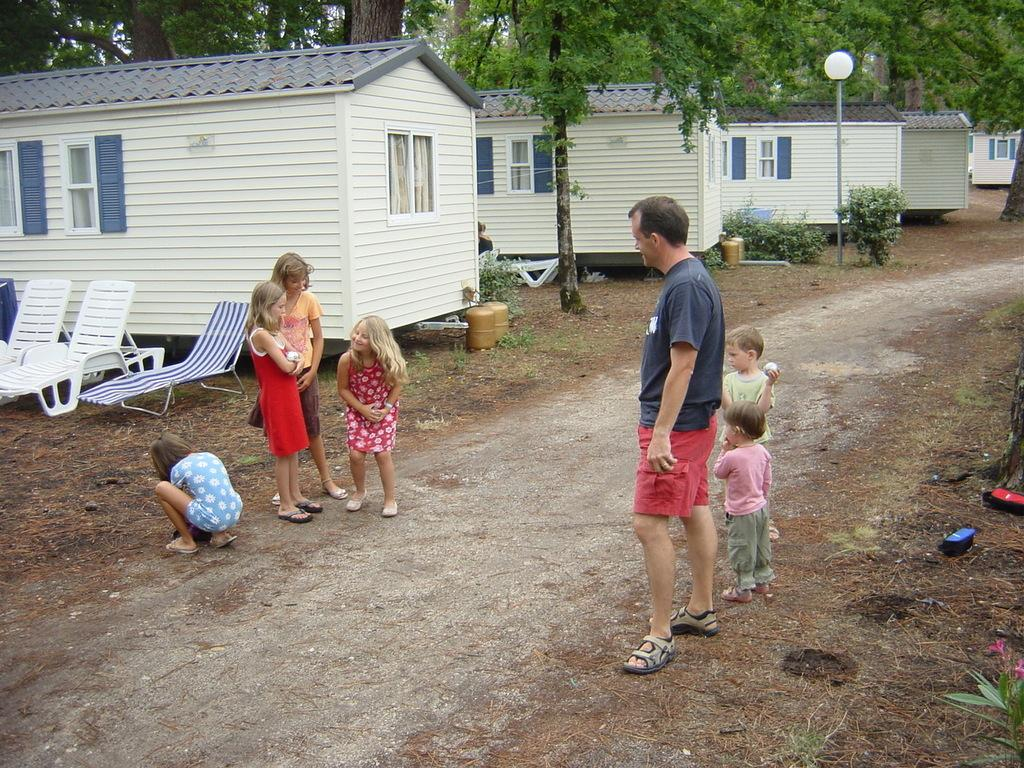What is happening on the road in the image? There are persons on the road in the image. What can be seen in the background of the image? There are sheds, trees, and a pole in the background of the image. What type of pencil is being used to write history on the pole in the image? There is no pencil or writing present in the image, and therefore no history being written on the pole. How much sugar is visible on the persons on the road in the image? There is no sugar visible on the persons on the road in the image. 